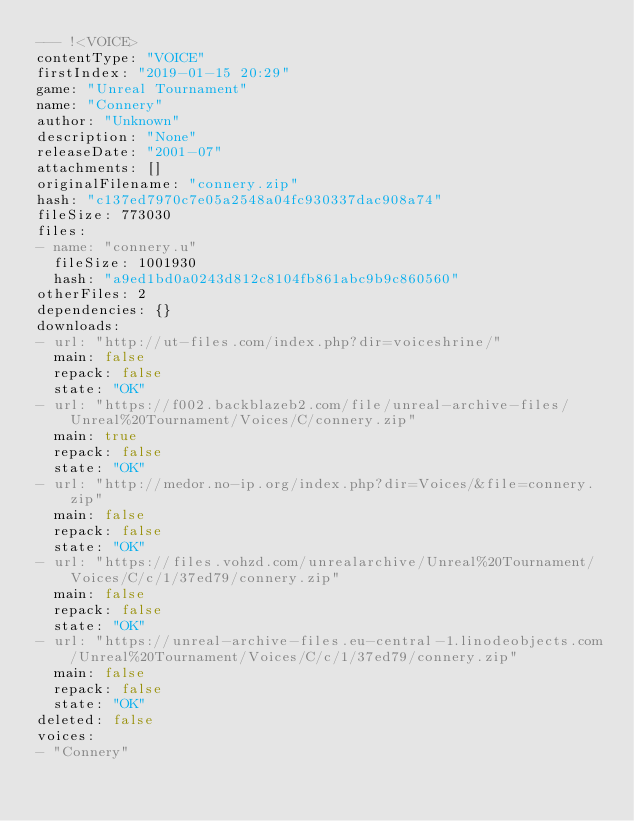<code> <loc_0><loc_0><loc_500><loc_500><_YAML_>--- !<VOICE>
contentType: "VOICE"
firstIndex: "2019-01-15 20:29"
game: "Unreal Tournament"
name: "Connery"
author: "Unknown"
description: "None"
releaseDate: "2001-07"
attachments: []
originalFilename: "connery.zip"
hash: "c137ed7970c7e05a2548a04fc930337dac908a74"
fileSize: 773030
files:
- name: "connery.u"
  fileSize: 1001930
  hash: "a9ed1bd0a0243d812c8104fb861abc9b9c860560"
otherFiles: 2
dependencies: {}
downloads:
- url: "http://ut-files.com/index.php?dir=voiceshrine/"
  main: false
  repack: false
  state: "OK"
- url: "https://f002.backblazeb2.com/file/unreal-archive-files/Unreal%20Tournament/Voices/C/connery.zip"
  main: true
  repack: false
  state: "OK"
- url: "http://medor.no-ip.org/index.php?dir=Voices/&file=connery.zip"
  main: false
  repack: false
  state: "OK"
- url: "https://files.vohzd.com/unrealarchive/Unreal%20Tournament/Voices/C/c/1/37ed79/connery.zip"
  main: false
  repack: false
  state: "OK"
- url: "https://unreal-archive-files.eu-central-1.linodeobjects.com/Unreal%20Tournament/Voices/C/c/1/37ed79/connery.zip"
  main: false
  repack: false
  state: "OK"
deleted: false
voices:
- "Connery"
</code> 